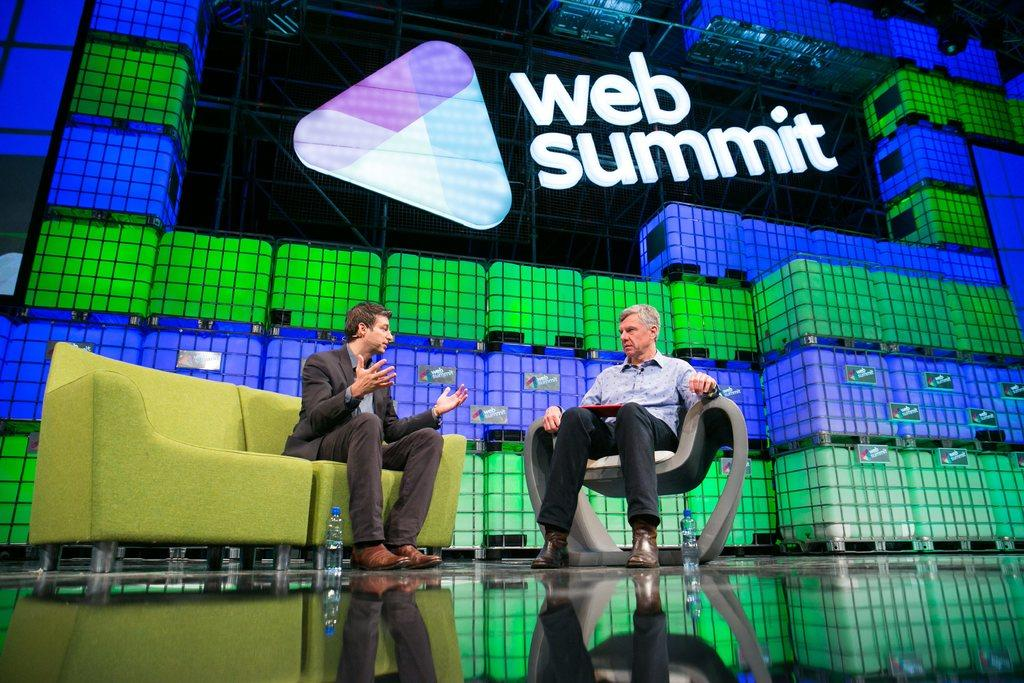How many people are in the image? There are two persons in the image. What are the two persons doing in the image? The two persons are sitting and talking. What can be seen in the image besides the two persons? There is a board with text visible in the image. What type of dress is the team wearing in the image? There is no team or dress present in the image; it features two persons sitting and talking. What attraction can be seen in the background of the image? There is no attraction visible in the image; it only shows two persons sitting and talking, along with a board with text. 